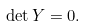Convert formula to latex. <formula><loc_0><loc_0><loc_500><loc_500>\det Y = 0 .</formula> 